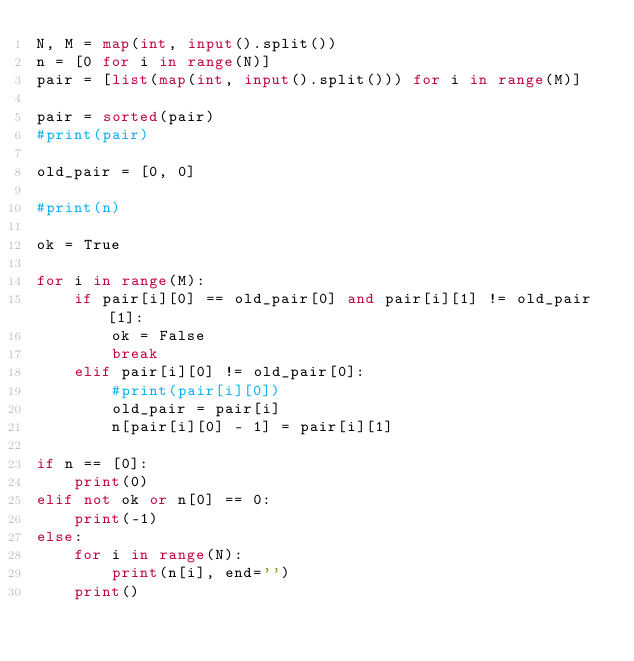Convert code to text. <code><loc_0><loc_0><loc_500><loc_500><_Python_>N, M = map(int, input().split())
n = [0 for i in range(N)]
pair = [list(map(int, input().split())) for i in range(M)]

pair = sorted(pair)
#print(pair)

old_pair = [0, 0]

#print(n)

ok = True

for i in range(M):
    if pair[i][0] == old_pair[0] and pair[i][1] != old_pair[1]:
        ok = False
        break
    elif pair[i][0] != old_pair[0]:
        #print(pair[i][0])
        old_pair = pair[i]
        n[pair[i][0] - 1] = pair[i][1]

if n == [0]:
    print(0)
elif not ok or n[0] == 0:
    print(-1)
else:
    for i in range(N):
        print(n[i], end='')
    print()</code> 